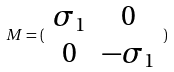<formula> <loc_0><loc_0><loc_500><loc_500>M = ( \begin{array} { c c } \sigma _ { 1 } & 0 \\ 0 & - \sigma _ { 1 } \end{array} )</formula> 